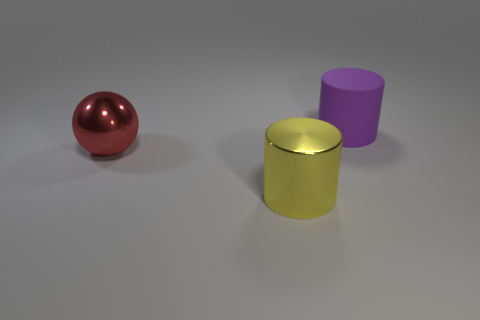Is there any other thing that has the same material as the purple cylinder?
Keep it short and to the point. No. Are there fewer purple rubber cylinders that are to the right of the big purple rubber thing than small rubber things?
Offer a terse response. No. Do the yellow object and the red object have the same shape?
Provide a succinct answer. No. Are there fewer matte things than small green rubber cylinders?
Your answer should be compact. No. There is a red sphere that is the same size as the yellow thing; what is it made of?
Keep it short and to the point. Metal. Are there more red shiny things than big shiny objects?
Your answer should be compact. No. What number of other things are the same color as the matte thing?
Make the answer very short. 0. What number of large things are right of the large red thing and behind the large yellow cylinder?
Give a very brief answer. 1. Are there more large yellow metal things that are in front of the red metallic ball than big yellow things that are behind the big yellow shiny cylinder?
Ensure brevity in your answer.  Yes. There is a object on the left side of the big yellow shiny thing; what is it made of?
Offer a terse response. Metal. 